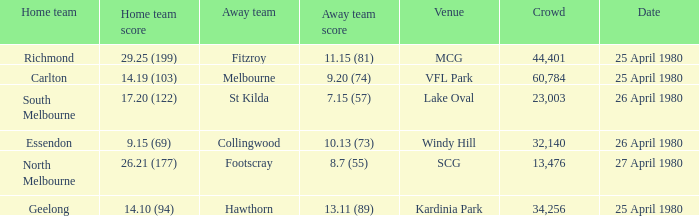Help me parse the entirety of this table. {'header': ['Home team', 'Home team score', 'Away team', 'Away team score', 'Venue', 'Crowd', 'Date'], 'rows': [['Richmond', '29.25 (199)', 'Fitzroy', '11.15 (81)', 'MCG', '44,401', '25 April 1980'], ['Carlton', '14.19 (103)', 'Melbourne', '9.20 (74)', 'VFL Park', '60,784', '25 April 1980'], ['South Melbourne', '17.20 (122)', 'St Kilda', '7.15 (57)', 'Lake Oval', '23,003', '26 April 1980'], ['Essendon', '9.15 (69)', 'Collingwood', '10.13 (73)', 'Windy Hill', '32,140', '26 April 1980'], ['North Melbourne', '26.21 (177)', 'Footscray', '8.7 (55)', 'SCG', '13,476', '27 April 1980'], ['Geelong', '14.10 (94)', 'Hawthorn', '13.11 (89)', 'Kardinia Park', '34,256', '25 April 1980']]} What wa the date of the North Melbourne home game? 27 April 1980. 